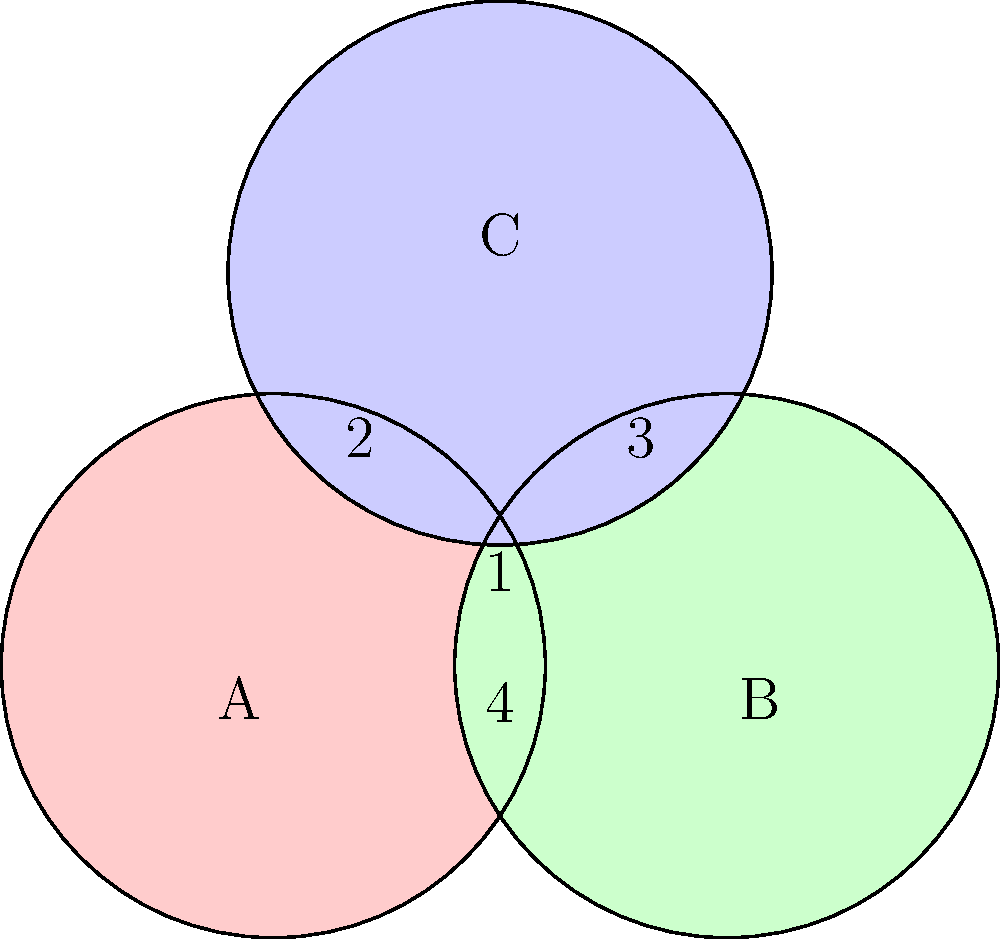In the coalition formation game represented by the Venn diagram, where each circle represents a player (A, B, and C) and the numbers in each region represent the value created by the corresponding coalition, calculate the Shapley value for player A. Round your answer to two decimal places. To calculate the Shapley value for player A, we need to follow these steps:

1) List all possible orderings of players:
   ABC, ACB, BAC, BCA, CAB, CBA

2) For each ordering, determine A's marginal contribution:

   ABC: A contributes 4
   ACB: A contributes 4
   BAC: A contributes 3
   BCA: A contributes 3
   CAB: A contributes 2
   CBA: A contributes 2

3) Calculate the average of these contributions:

   $\text{Shapley Value}_A = \frac{4 + 4 + 3 + 3 + 2 + 2}{6} = \frac{18}{6} = 3$

Therefore, the Shapley value for player A is 3.

This value represents the average marginal contribution of player A across all possible coalition formation sequences, reflecting their power and importance in the game based on their ability to create value in different coalitions.
Answer: 3.00 